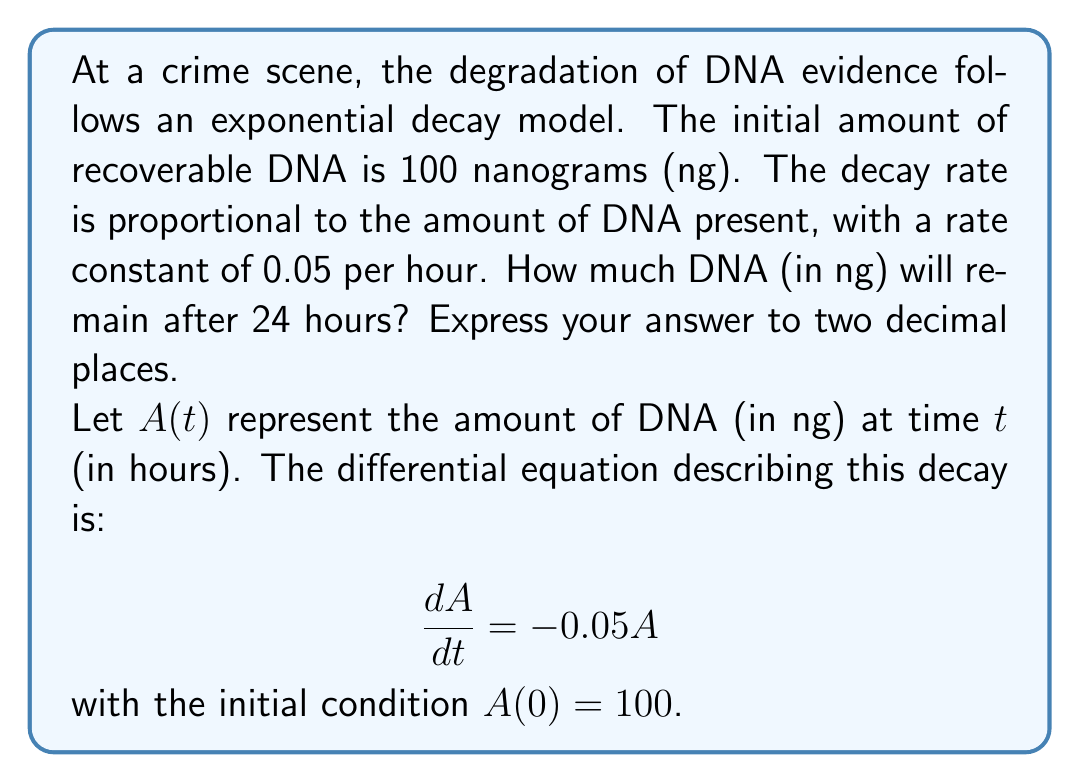Provide a solution to this math problem. To solve this ordinary differential equation:

1) The general solution for this type of first-order linear differential equation is:

   $A(t) = Ce^{-0.05t}$

   where $C$ is a constant we need to determine.

2) Using the initial condition $A(0) = 100$:

   $100 = Ce^{-0.05(0)}$
   $100 = C$

3) Therefore, the specific solution is:

   $A(t) = 100e^{-0.05t}$

4) To find the amount of DNA after 24 hours, we substitute $t = 24$:

   $A(24) = 100e^{-0.05(24)}$

5) Calculating:

   $A(24) = 100e^{-1.2}$
   $A(24) = 100 \cdot 0.301194...$ 
   $A(24) = 30.1194...$

6) Rounding to two decimal places:

   $A(24) \approx 30.12$ ng
Answer: 30.12 ng 